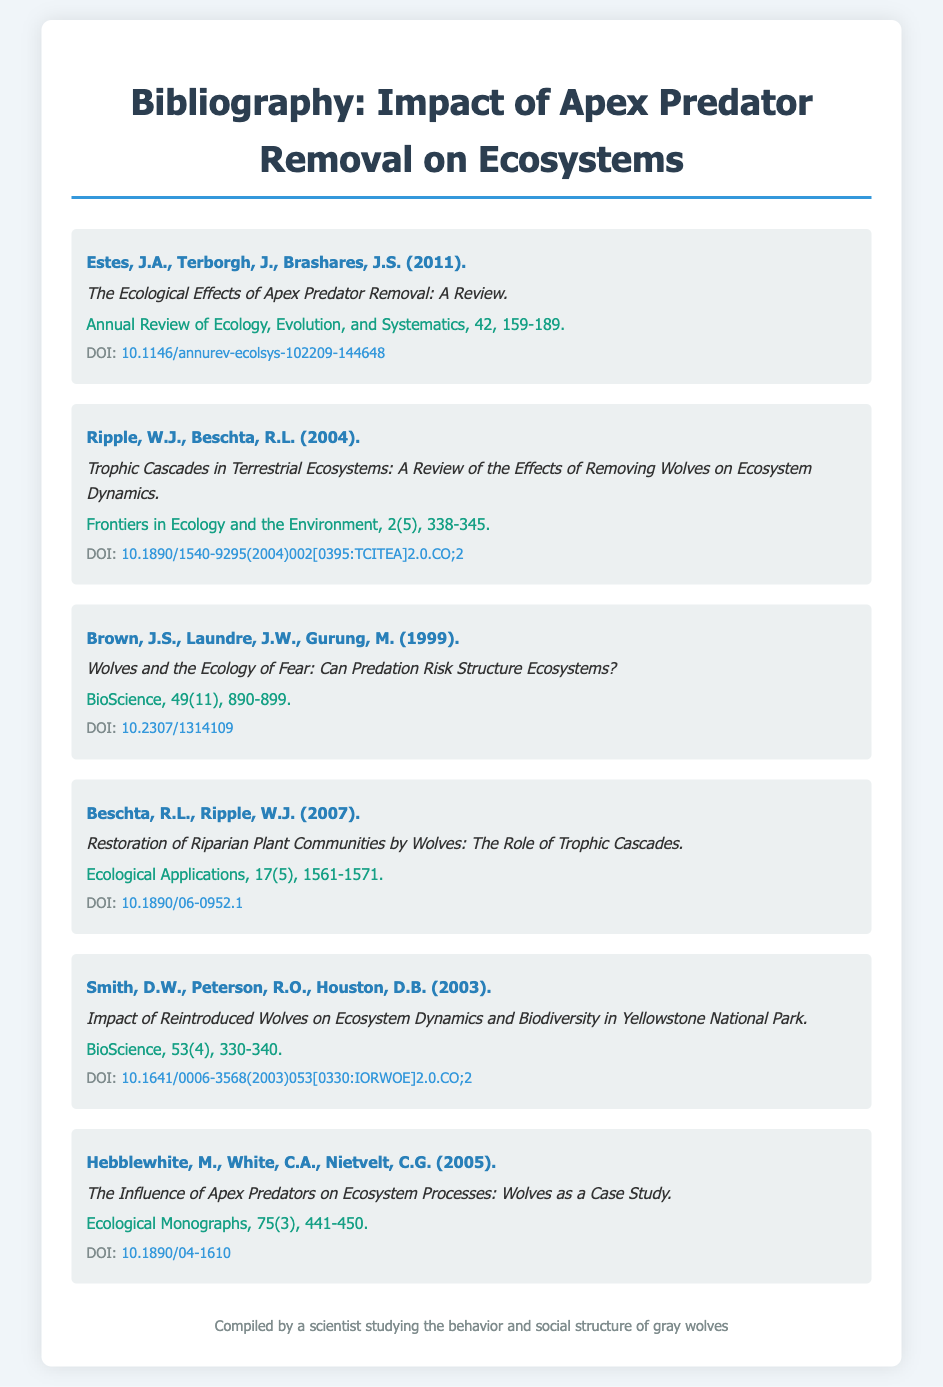What is the title of the first item in the bibliography? The title of the first item is listed directly below the author's names in the document.
Answer: The Ecological Effects of Apex Predator Removal: A Review Who are the authors of the second item? The authors of the second item are provided at the beginning of each bibliography entry.
Answer: Ripple, W.J., Beschta, R.L In what year was the article by Smith et al. published? The publication year is usually included with each reference; it appears right after the authors' names.
Answer: 2003 Which journal published the article titled "Wolves and the Ecology of Fear"? The journal name is located right after the title in each bibliography item.
Answer: BioScience What is the DOI link format used in this bibliography? The DOI is presented at the end of each bibliography entry and follows a consistent link pattern.
Answer: https://doi.org/.. How many articles in the bibliography are authored by Ripple? The count can be provided by reviewing the document for occurrences of the author’s name.
Answer: Two Which study focuses specifically on Yellowstone National Park? The focus of the study can be identified through the titles and stated details in the bibliography.
Answer: Impact of Reintroduced Wolves on Ecosystem Dynamics and Biodiversity in Yellowstone National Park What is the volume number of the Annual Review of Ecology, Evolution, and Systematics? The volume number is typically found next to the journal name and year.
Answer: 42 